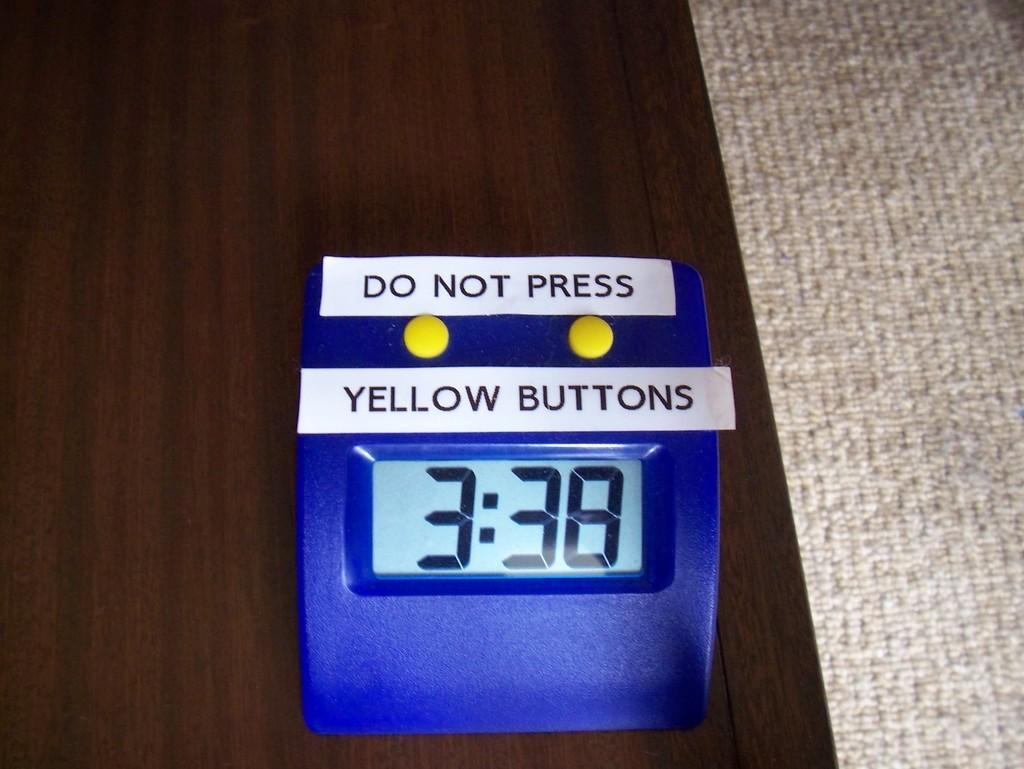<image>
Offer a succinct explanation of the picture presented. A blue digital clock with the time of 3:38 with a sign saying "do not press yellow buttons" 